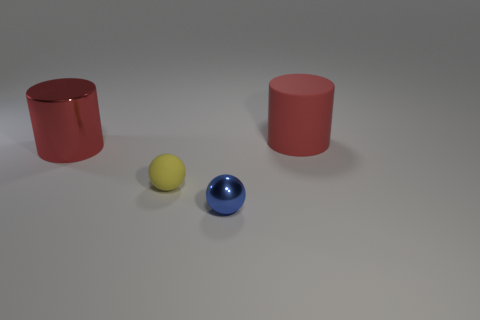Add 4 big cyan matte balls. How many objects exist? 8 Add 2 shiny things. How many shiny things exist? 4 Subtract 0 purple spheres. How many objects are left? 4 Subtract all big rubber cubes. Subtract all tiny blue spheres. How many objects are left? 3 Add 2 blue metallic things. How many blue metallic things are left? 3 